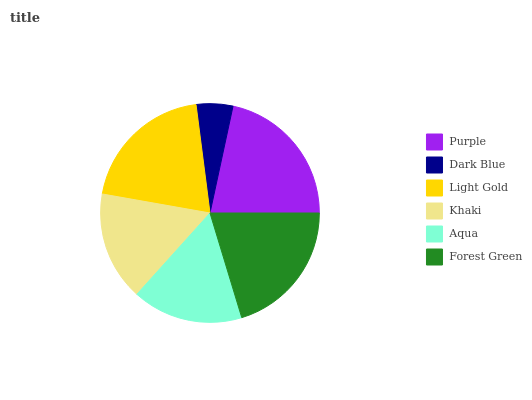Is Dark Blue the minimum?
Answer yes or no. Yes. Is Purple the maximum?
Answer yes or no. Yes. Is Light Gold the minimum?
Answer yes or no. No. Is Light Gold the maximum?
Answer yes or no. No. Is Light Gold greater than Dark Blue?
Answer yes or no. Yes. Is Dark Blue less than Light Gold?
Answer yes or no. Yes. Is Dark Blue greater than Light Gold?
Answer yes or no. No. Is Light Gold less than Dark Blue?
Answer yes or no. No. Is Light Gold the high median?
Answer yes or no. Yes. Is Aqua the low median?
Answer yes or no. Yes. Is Purple the high median?
Answer yes or no. No. Is Purple the low median?
Answer yes or no. No. 